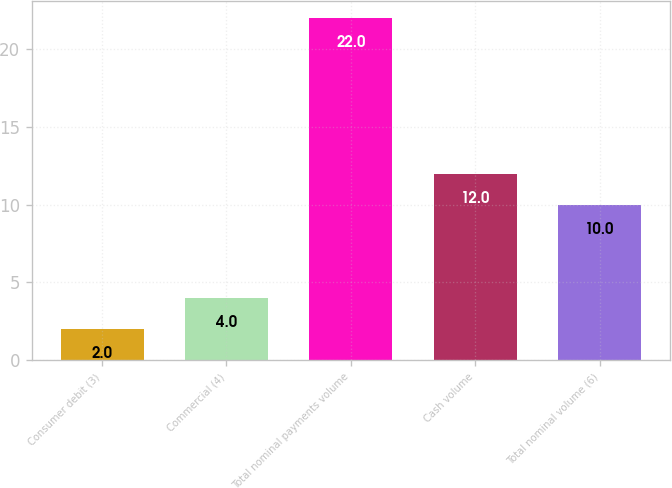<chart> <loc_0><loc_0><loc_500><loc_500><bar_chart><fcel>Consumer debit (3)<fcel>Commercial (4)<fcel>Total nominal payments volume<fcel>Cash volume<fcel>Total nominal volume (6)<nl><fcel>2<fcel>4<fcel>22<fcel>12<fcel>10<nl></chart> 